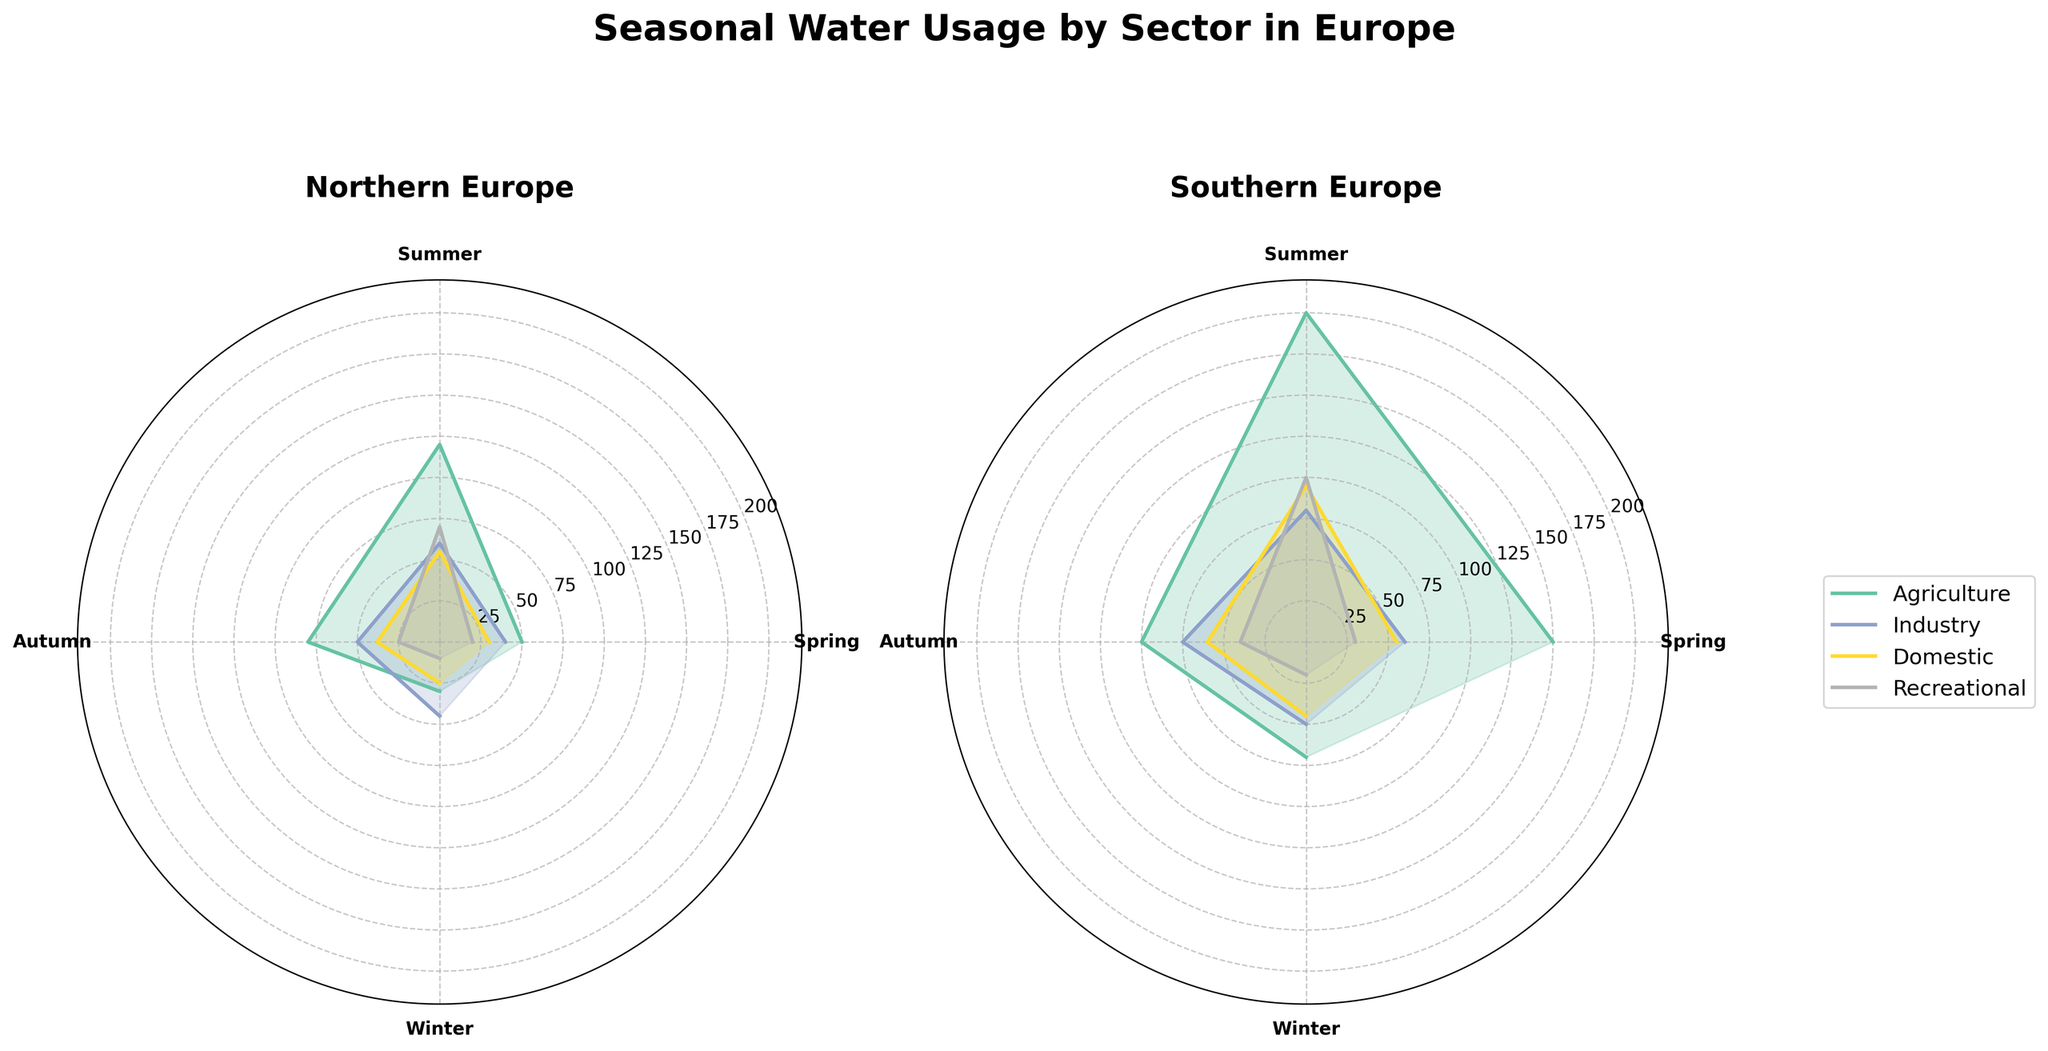What's the title of the figure? The title is located at the top of the figure and reads "Seasonal Water Usage by Sector in Europe"
Answer: Seasonal Water Usage by Sector in Europe Which sector uses the most water in Northern Europe during the summer season? To answer this, we look for the highest value in Northern Europe’s summer season slice of the polar plot and identify the sector. The largest value corresponds to the agriculture sector.
Answer: Agriculture What are the total water usage values for the recreational sector across all seasons in Southern Europe? Add the values for recreational water usage in Southern Europe: Spring (30), Summer (100), Autumn (40), and Winter (20). This results in 30 + 100 + 40 + 20 = 190.
Answer: 190 million cubic meters Which region shows more seasonal variation in agricultural water usage, Northern Europe or Southern Europe? Examine the extent of variation in agricultural water usage across all seasons for both regions. Southern Europe shows a larger spread (150 in Spring to 200 in Summer, down to 70 in Winter) compared to Northern Europe (50 in Spring to 120 in Summer, down to 30 in Winter).
Answer: Southern Europe In which season does the domestic sector in Southern Europe use the least water? Check the values for the domestic sector across all seasons in Southern Europe. The smallest value is found in Winter (45 million cubic meters).
Answer: Winter Compare the water usage in the industry sector between Northern and Southern Europe during autumn. Which region uses more? Check the industrial water usage values for Autumn. Northern Europe uses 50 million cubic meters, and Southern Europe uses 75 million cubic meters.
Answer: Southern Europe During which season does Northern Europe use the least water for recreational purposes? Find the lowest value for recreational usage in Northern Europe across all seasons. The smallest value is in Winter (10 million cubic meters).
Answer: Winter What is the difference in agricultural water usage between summer and winter in Southern Europe? Subtract the winter value from the summer value for agricultural usage in Southern Europe: 200 - 70 = 130.
Answer: 130 million cubic meters Which sector, industry or domestic, uses more water on average throughout the year in Northern Europe? Calculate the average for both sectors. Industry: (40+60+50+45)/4 = 48.75, Domestic: (30+55+38+25)/4 = 37. Average is higher for industry sector.
Answer: Industry What is the sum of water usage for all sectors during Spring in Northern Europe? Add the water usage values for all sectors during Spring in Northern Europe: Agriculture (50), Industry (40), Domestic (30), Recreational (20). Thus, 50+40+30+20 = 140.
Answer: 140 million cubic meters 